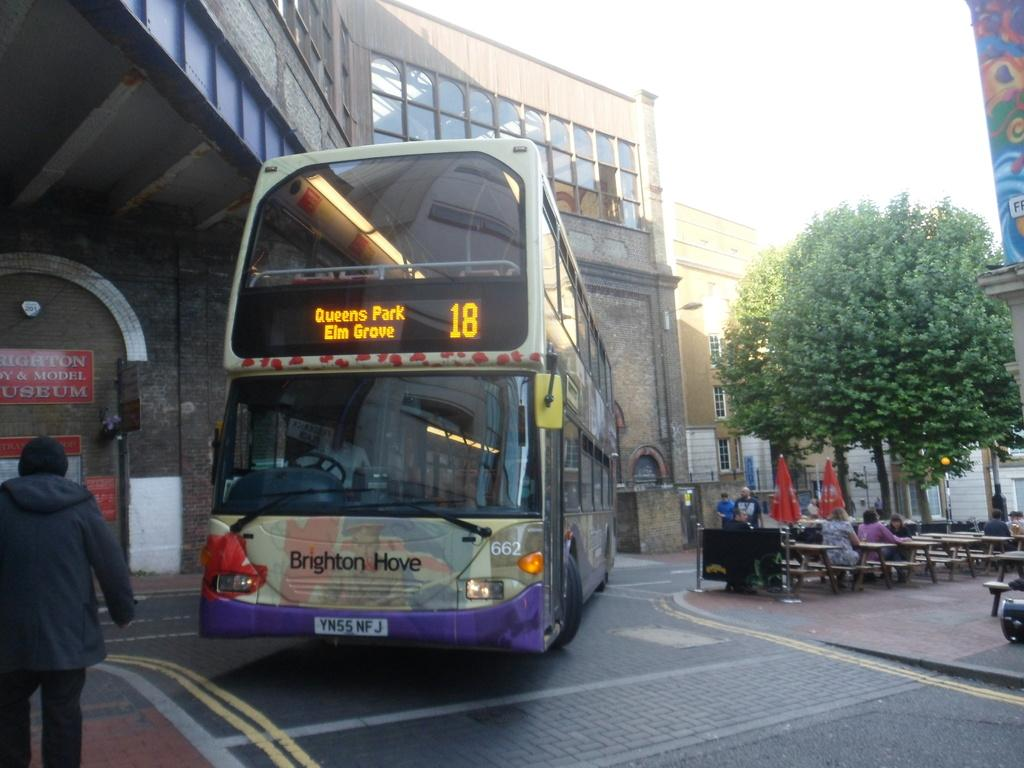What type of vehicle is on the road in the image? There is a bus on the road in the image. What type of seating is available in the image? There are benches in the image. What objects are present to provide shade or protection from the elements? There are umbrellas in the image. What type of plant is visible in the image? There is a tree in the image. What type of signage is present in the image? There is a banner in the image. What type of structures are visible in the image? There are buildings with windows in the image. Are there any living beings in the image? Yes, there are people in the image. What is visible in the background of the image? The sky is visible in the background of the image. What type of beast can be seen roaming around the bus in the image? There is no beast present in the image; it features a bus on the road with other elements mentioned in the facts. 